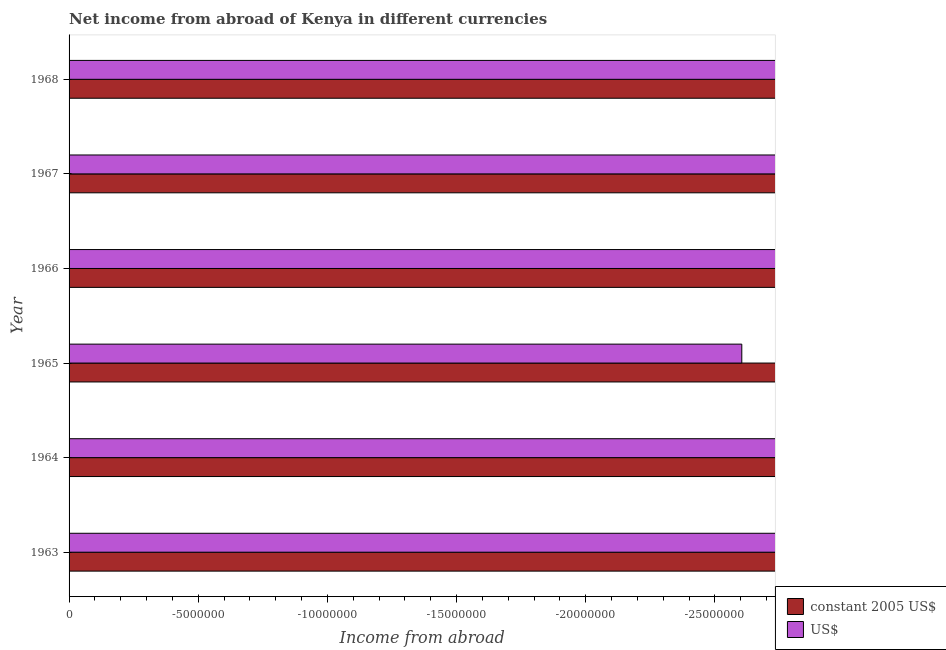Are the number of bars per tick equal to the number of legend labels?
Your response must be concise. No. Are the number of bars on each tick of the Y-axis equal?
Your answer should be compact. Yes. How many bars are there on the 6th tick from the bottom?
Provide a succinct answer. 0. What is the label of the 2nd group of bars from the top?
Offer a very short reply. 1967. Across all years, what is the minimum income from abroad in constant 2005 us$?
Ensure brevity in your answer.  0. What is the average income from abroad in constant 2005 us$ per year?
Your answer should be very brief. 0. In how many years, is the income from abroad in constant 2005 us$ greater than -1000000 units?
Your answer should be very brief. 0. How many bars are there?
Ensure brevity in your answer.  0. How many years are there in the graph?
Your answer should be very brief. 6. Does the graph contain grids?
Provide a short and direct response. No. How are the legend labels stacked?
Your answer should be compact. Vertical. What is the title of the graph?
Offer a terse response. Net income from abroad of Kenya in different currencies. What is the label or title of the X-axis?
Your answer should be compact. Income from abroad. What is the Income from abroad in US$ in 1963?
Make the answer very short. 0. What is the Income from abroad in constant 2005 US$ in 1964?
Your answer should be very brief. 0. What is the Income from abroad in constant 2005 US$ in 1965?
Make the answer very short. 0. What is the Income from abroad of US$ in 1965?
Give a very brief answer. 0. What is the Income from abroad of constant 2005 US$ in 1966?
Your answer should be very brief. 0. What is the Income from abroad in US$ in 1966?
Offer a very short reply. 0. What is the Income from abroad of constant 2005 US$ in 1967?
Your response must be concise. 0. What is the total Income from abroad in constant 2005 US$ in the graph?
Ensure brevity in your answer.  0. What is the total Income from abroad of US$ in the graph?
Your response must be concise. 0. What is the average Income from abroad of US$ per year?
Keep it short and to the point. 0. 